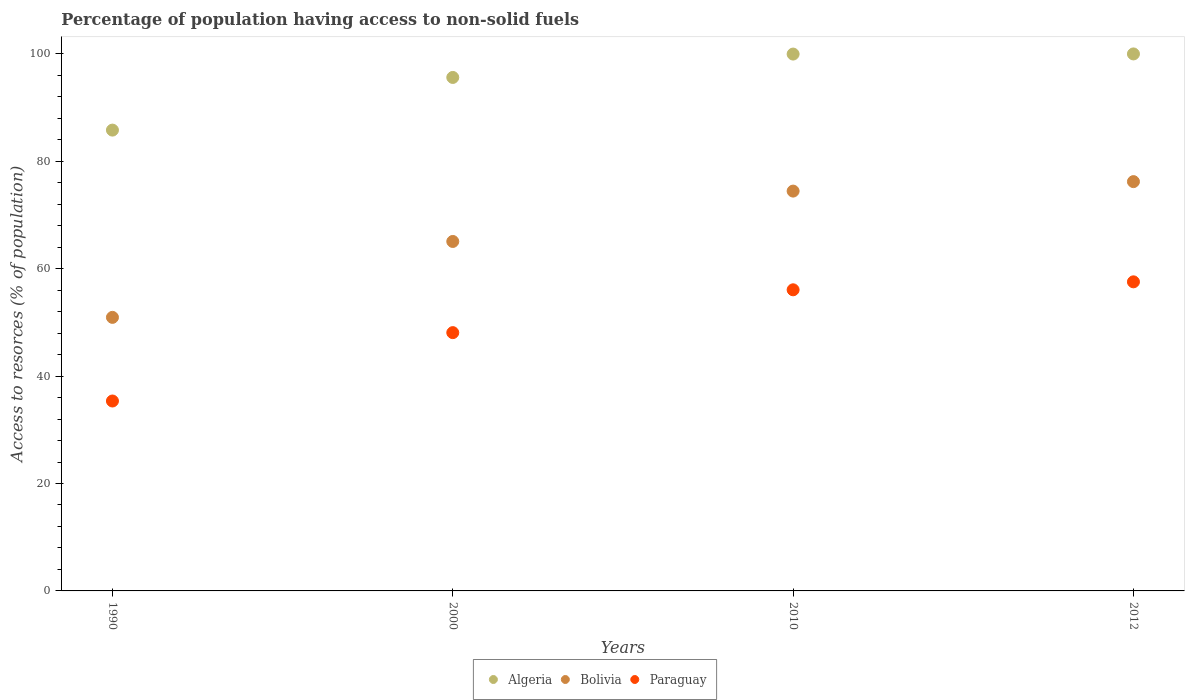What is the percentage of population having access to non-solid fuels in Algeria in 2010?
Provide a short and direct response. 99.96. Across all years, what is the maximum percentage of population having access to non-solid fuels in Paraguay?
Your answer should be very brief. 57.55. Across all years, what is the minimum percentage of population having access to non-solid fuels in Bolivia?
Provide a succinct answer. 50.94. What is the total percentage of population having access to non-solid fuels in Algeria in the graph?
Your response must be concise. 381.37. What is the difference between the percentage of population having access to non-solid fuels in Algeria in 1990 and that in 2000?
Provide a succinct answer. -9.81. What is the difference between the percentage of population having access to non-solid fuels in Bolivia in 2000 and the percentage of population having access to non-solid fuels in Algeria in 2010?
Your answer should be very brief. -34.89. What is the average percentage of population having access to non-solid fuels in Algeria per year?
Make the answer very short. 95.34. In the year 1990, what is the difference between the percentage of population having access to non-solid fuels in Paraguay and percentage of population having access to non-solid fuels in Algeria?
Provide a succinct answer. -50.44. In how many years, is the percentage of population having access to non-solid fuels in Bolivia greater than 28 %?
Keep it short and to the point. 4. What is the ratio of the percentage of population having access to non-solid fuels in Paraguay in 1990 to that in 2010?
Your response must be concise. 0.63. Is the difference between the percentage of population having access to non-solid fuels in Paraguay in 2000 and 2010 greater than the difference between the percentage of population having access to non-solid fuels in Algeria in 2000 and 2010?
Provide a succinct answer. No. What is the difference between the highest and the second highest percentage of population having access to non-solid fuels in Bolivia?
Provide a succinct answer. 1.76. What is the difference between the highest and the lowest percentage of population having access to non-solid fuels in Algeria?
Your answer should be compact. 14.19. Is the sum of the percentage of population having access to non-solid fuels in Bolivia in 2000 and 2012 greater than the maximum percentage of population having access to non-solid fuels in Algeria across all years?
Provide a short and direct response. Yes. Is it the case that in every year, the sum of the percentage of population having access to non-solid fuels in Bolivia and percentage of population having access to non-solid fuels in Paraguay  is greater than the percentage of population having access to non-solid fuels in Algeria?
Make the answer very short. Yes. Is the percentage of population having access to non-solid fuels in Paraguay strictly greater than the percentage of population having access to non-solid fuels in Algeria over the years?
Your response must be concise. No. How many dotlines are there?
Your answer should be compact. 3. How many years are there in the graph?
Provide a succinct answer. 4. Does the graph contain any zero values?
Provide a succinct answer. No. Does the graph contain grids?
Provide a short and direct response. No. What is the title of the graph?
Your answer should be compact. Percentage of population having access to non-solid fuels. Does "Vietnam" appear as one of the legend labels in the graph?
Your answer should be compact. No. What is the label or title of the X-axis?
Give a very brief answer. Years. What is the label or title of the Y-axis?
Provide a short and direct response. Access to resorces (% of population). What is the Access to resorces (% of population) of Algeria in 1990?
Your answer should be very brief. 85.8. What is the Access to resorces (% of population) in Bolivia in 1990?
Offer a very short reply. 50.94. What is the Access to resorces (% of population) in Paraguay in 1990?
Offer a very short reply. 35.36. What is the Access to resorces (% of population) in Algeria in 2000?
Offer a very short reply. 95.61. What is the Access to resorces (% of population) of Bolivia in 2000?
Provide a short and direct response. 65.07. What is the Access to resorces (% of population) in Paraguay in 2000?
Give a very brief answer. 48.09. What is the Access to resorces (% of population) of Algeria in 2010?
Offer a terse response. 99.96. What is the Access to resorces (% of population) in Bolivia in 2010?
Provide a succinct answer. 74.45. What is the Access to resorces (% of population) in Paraguay in 2010?
Make the answer very short. 56.07. What is the Access to resorces (% of population) in Algeria in 2012?
Your response must be concise. 99.99. What is the Access to resorces (% of population) in Bolivia in 2012?
Offer a very short reply. 76.21. What is the Access to resorces (% of population) in Paraguay in 2012?
Ensure brevity in your answer.  57.55. Across all years, what is the maximum Access to resorces (% of population) in Algeria?
Provide a short and direct response. 99.99. Across all years, what is the maximum Access to resorces (% of population) in Bolivia?
Provide a short and direct response. 76.21. Across all years, what is the maximum Access to resorces (% of population) of Paraguay?
Provide a short and direct response. 57.55. Across all years, what is the minimum Access to resorces (% of population) in Algeria?
Your answer should be very brief. 85.8. Across all years, what is the minimum Access to resorces (% of population) of Bolivia?
Make the answer very short. 50.94. Across all years, what is the minimum Access to resorces (% of population) of Paraguay?
Keep it short and to the point. 35.36. What is the total Access to resorces (% of population) in Algeria in the graph?
Your answer should be very brief. 381.37. What is the total Access to resorces (% of population) in Bolivia in the graph?
Make the answer very short. 266.67. What is the total Access to resorces (% of population) of Paraguay in the graph?
Make the answer very short. 197.08. What is the difference between the Access to resorces (% of population) of Algeria in 1990 and that in 2000?
Offer a terse response. -9.81. What is the difference between the Access to resorces (% of population) of Bolivia in 1990 and that in 2000?
Give a very brief answer. -14.13. What is the difference between the Access to resorces (% of population) of Paraguay in 1990 and that in 2000?
Make the answer very short. -12.73. What is the difference between the Access to resorces (% of population) of Algeria in 1990 and that in 2010?
Offer a very short reply. -14.16. What is the difference between the Access to resorces (% of population) in Bolivia in 1990 and that in 2010?
Your answer should be very brief. -23.51. What is the difference between the Access to resorces (% of population) of Paraguay in 1990 and that in 2010?
Your response must be concise. -20.71. What is the difference between the Access to resorces (% of population) in Algeria in 1990 and that in 2012?
Ensure brevity in your answer.  -14.19. What is the difference between the Access to resorces (% of population) of Bolivia in 1990 and that in 2012?
Your answer should be compact. -25.28. What is the difference between the Access to resorces (% of population) in Paraguay in 1990 and that in 2012?
Offer a terse response. -22.19. What is the difference between the Access to resorces (% of population) of Algeria in 2000 and that in 2010?
Your answer should be very brief. -4.35. What is the difference between the Access to resorces (% of population) of Bolivia in 2000 and that in 2010?
Provide a short and direct response. -9.38. What is the difference between the Access to resorces (% of population) in Paraguay in 2000 and that in 2010?
Ensure brevity in your answer.  -7.98. What is the difference between the Access to resorces (% of population) of Algeria in 2000 and that in 2012?
Make the answer very short. -4.38. What is the difference between the Access to resorces (% of population) of Bolivia in 2000 and that in 2012?
Your answer should be compact. -11.14. What is the difference between the Access to resorces (% of population) in Paraguay in 2000 and that in 2012?
Your response must be concise. -9.46. What is the difference between the Access to resorces (% of population) of Algeria in 2010 and that in 2012?
Offer a terse response. -0.03. What is the difference between the Access to resorces (% of population) of Bolivia in 2010 and that in 2012?
Make the answer very short. -1.76. What is the difference between the Access to resorces (% of population) of Paraguay in 2010 and that in 2012?
Give a very brief answer. -1.48. What is the difference between the Access to resorces (% of population) in Algeria in 1990 and the Access to resorces (% of population) in Bolivia in 2000?
Offer a very short reply. 20.73. What is the difference between the Access to resorces (% of population) in Algeria in 1990 and the Access to resorces (% of population) in Paraguay in 2000?
Your response must be concise. 37.71. What is the difference between the Access to resorces (% of population) of Bolivia in 1990 and the Access to resorces (% of population) of Paraguay in 2000?
Make the answer very short. 2.84. What is the difference between the Access to resorces (% of population) of Algeria in 1990 and the Access to resorces (% of population) of Bolivia in 2010?
Your answer should be compact. 11.36. What is the difference between the Access to resorces (% of population) of Algeria in 1990 and the Access to resorces (% of population) of Paraguay in 2010?
Your answer should be compact. 29.74. What is the difference between the Access to resorces (% of population) of Bolivia in 1990 and the Access to resorces (% of population) of Paraguay in 2010?
Offer a very short reply. -5.13. What is the difference between the Access to resorces (% of population) of Algeria in 1990 and the Access to resorces (% of population) of Bolivia in 2012?
Your answer should be very brief. 9.59. What is the difference between the Access to resorces (% of population) of Algeria in 1990 and the Access to resorces (% of population) of Paraguay in 2012?
Give a very brief answer. 28.25. What is the difference between the Access to resorces (% of population) of Bolivia in 1990 and the Access to resorces (% of population) of Paraguay in 2012?
Your answer should be compact. -6.62. What is the difference between the Access to resorces (% of population) of Algeria in 2000 and the Access to resorces (% of population) of Bolivia in 2010?
Your answer should be compact. 21.16. What is the difference between the Access to resorces (% of population) in Algeria in 2000 and the Access to resorces (% of population) in Paraguay in 2010?
Keep it short and to the point. 39.54. What is the difference between the Access to resorces (% of population) of Bolivia in 2000 and the Access to resorces (% of population) of Paraguay in 2010?
Your response must be concise. 9. What is the difference between the Access to resorces (% of population) in Algeria in 2000 and the Access to resorces (% of population) in Bolivia in 2012?
Your answer should be very brief. 19.4. What is the difference between the Access to resorces (% of population) of Algeria in 2000 and the Access to resorces (% of population) of Paraguay in 2012?
Offer a very short reply. 38.06. What is the difference between the Access to resorces (% of population) of Bolivia in 2000 and the Access to resorces (% of population) of Paraguay in 2012?
Provide a succinct answer. 7.52. What is the difference between the Access to resorces (% of population) in Algeria in 2010 and the Access to resorces (% of population) in Bolivia in 2012?
Make the answer very short. 23.75. What is the difference between the Access to resorces (% of population) in Algeria in 2010 and the Access to resorces (% of population) in Paraguay in 2012?
Offer a terse response. 42.41. What is the difference between the Access to resorces (% of population) of Bolivia in 2010 and the Access to resorces (% of population) of Paraguay in 2012?
Offer a very short reply. 16.9. What is the average Access to resorces (% of population) of Algeria per year?
Give a very brief answer. 95.34. What is the average Access to resorces (% of population) in Bolivia per year?
Make the answer very short. 66.67. What is the average Access to resorces (% of population) of Paraguay per year?
Keep it short and to the point. 49.27. In the year 1990, what is the difference between the Access to resorces (% of population) of Algeria and Access to resorces (% of population) of Bolivia?
Your answer should be very brief. 34.87. In the year 1990, what is the difference between the Access to resorces (% of population) of Algeria and Access to resorces (% of population) of Paraguay?
Offer a terse response. 50.44. In the year 1990, what is the difference between the Access to resorces (% of population) of Bolivia and Access to resorces (% of population) of Paraguay?
Make the answer very short. 15.57. In the year 2000, what is the difference between the Access to resorces (% of population) in Algeria and Access to resorces (% of population) in Bolivia?
Provide a succinct answer. 30.54. In the year 2000, what is the difference between the Access to resorces (% of population) of Algeria and Access to resorces (% of population) of Paraguay?
Your response must be concise. 47.52. In the year 2000, what is the difference between the Access to resorces (% of population) in Bolivia and Access to resorces (% of population) in Paraguay?
Keep it short and to the point. 16.98. In the year 2010, what is the difference between the Access to resorces (% of population) of Algeria and Access to resorces (% of population) of Bolivia?
Ensure brevity in your answer.  25.51. In the year 2010, what is the difference between the Access to resorces (% of population) of Algeria and Access to resorces (% of population) of Paraguay?
Your answer should be very brief. 43.89. In the year 2010, what is the difference between the Access to resorces (% of population) in Bolivia and Access to resorces (% of population) in Paraguay?
Your answer should be very brief. 18.38. In the year 2012, what is the difference between the Access to resorces (% of population) in Algeria and Access to resorces (% of population) in Bolivia?
Make the answer very short. 23.78. In the year 2012, what is the difference between the Access to resorces (% of population) of Algeria and Access to resorces (% of population) of Paraguay?
Provide a succinct answer. 42.44. In the year 2012, what is the difference between the Access to resorces (% of population) of Bolivia and Access to resorces (% of population) of Paraguay?
Keep it short and to the point. 18.66. What is the ratio of the Access to resorces (% of population) in Algeria in 1990 to that in 2000?
Give a very brief answer. 0.9. What is the ratio of the Access to resorces (% of population) of Bolivia in 1990 to that in 2000?
Offer a terse response. 0.78. What is the ratio of the Access to resorces (% of population) of Paraguay in 1990 to that in 2000?
Your response must be concise. 0.74. What is the ratio of the Access to resorces (% of population) of Algeria in 1990 to that in 2010?
Provide a succinct answer. 0.86. What is the ratio of the Access to resorces (% of population) of Bolivia in 1990 to that in 2010?
Make the answer very short. 0.68. What is the ratio of the Access to resorces (% of population) of Paraguay in 1990 to that in 2010?
Your response must be concise. 0.63. What is the ratio of the Access to resorces (% of population) of Algeria in 1990 to that in 2012?
Your answer should be very brief. 0.86. What is the ratio of the Access to resorces (% of population) of Bolivia in 1990 to that in 2012?
Make the answer very short. 0.67. What is the ratio of the Access to resorces (% of population) of Paraguay in 1990 to that in 2012?
Your answer should be compact. 0.61. What is the ratio of the Access to resorces (% of population) of Algeria in 2000 to that in 2010?
Your answer should be compact. 0.96. What is the ratio of the Access to resorces (% of population) in Bolivia in 2000 to that in 2010?
Keep it short and to the point. 0.87. What is the ratio of the Access to resorces (% of population) in Paraguay in 2000 to that in 2010?
Give a very brief answer. 0.86. What is the ratio of the Access to resorces (% of population) of Algeria in 2000 to that in 2012?
Make the answer very short. 0.96. What is the ratio of the Access to resorces (% of population) in Bolivia in 2000 to that in 2012?
Make the answer very short. 0.85. What is the ratio of the Access to resorces (% of population) of Paraguay in 2000 to that in 2012?
Offer a terse response. 0.84. What is the ratio of the Access to resorces (% of population) of Algeria in 2010 to that in 2012?
Provide a short and direct response. 1. What is the ratio of the Access to resorces (% of population) of Bolivia in 2010 to that in 2012?
Ensure brevity in your answer.  0.98. What is the ratio of the Access to resorces (% of population) in Paraguay in 2010 to that in 2012?
Offer a very short reply. 0.97. What is the difference between the highest and the second highest Access to resorces (% of population) in Algeria?
Offer a terse response. 0.03. What is the difference between the highest and the second highest Access to resorces (% of population) of Bolivia?
Provide a succinct answer. 1.76. What is the difference between the highest and the second highest Access to resorces (% of population) in Paraguay?
Your response must be concise. 1.48. What is the difference between the highest and the lowest Access to resorces (% of population) of Algeria?
Offer a very short reply. 14.19. What is the difference between the highest and the lowest Access to resorces (% of population) of Bolivia?
Provide a short and direct response. 25.28. What is the difference between the highest and the lowest Access to resorces (% of population) of Paraguay?
Offer a very short reply. 22.19. 